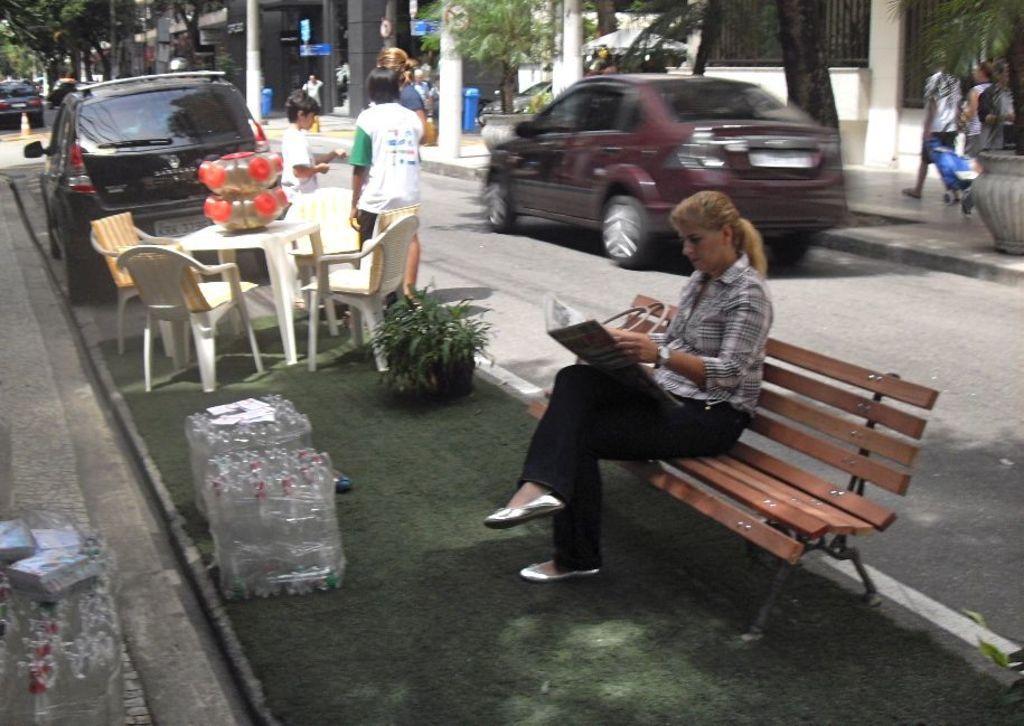Can you describe this image briefly? In this picture we can see a woman sitting on the bench. This is grass and there is a plant. Here we can see vehicles on the road. These are the chairs and this is the table. Here we can see two persons standing on the road. These are the trees. And there is a pole. 